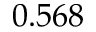Convert formula to latex. <formula><loc_0><loc_0><loc_500><loc_500>0 . 5 6 8</formula> 